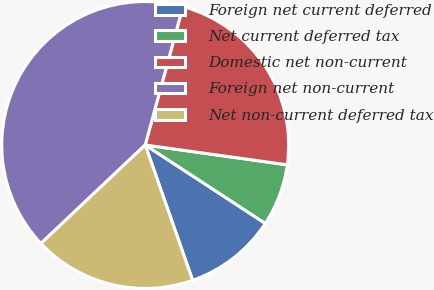<chart> <loc_0><loc_0><loc_500><loc_500><pie_chart><fcel>Foreign net current deferred<fcel>Net current deferred tax<fcel>Domestic net non-current<fcel>Foreign net non-current<fcel>Net non-current deferred tax<nl><fcel>10.43%<fcel>7.0%<fcel>22.97%<fcel>41.28%<fcel>18.31%<nl></chart> 